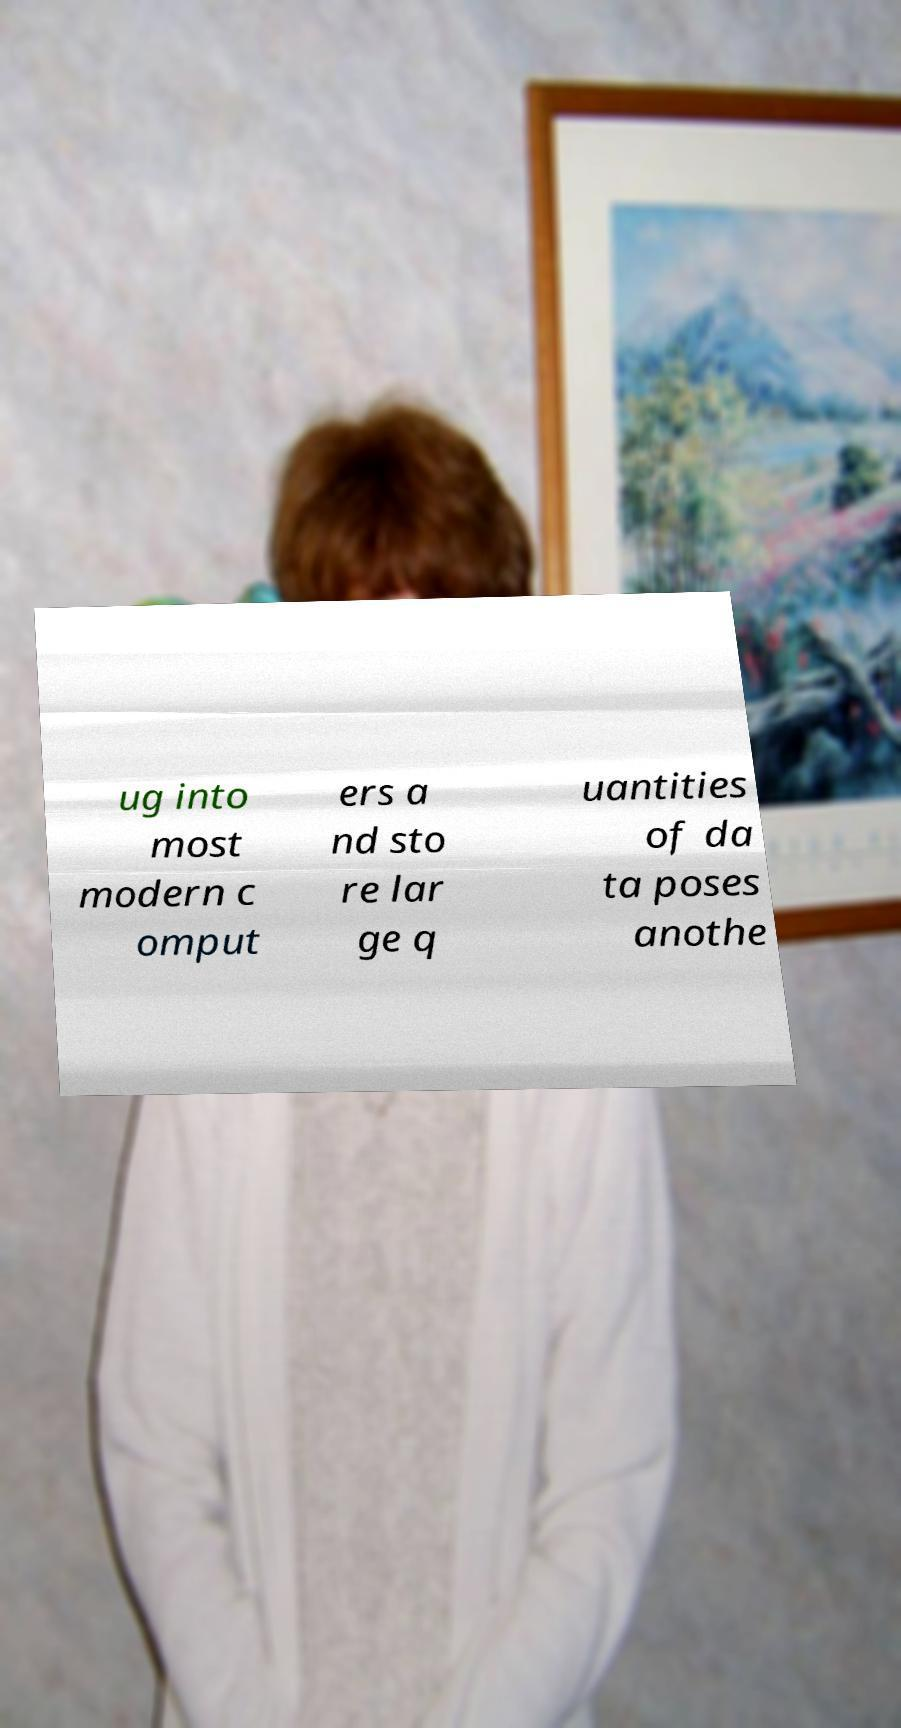Please identify and transcribe the text found in this image. ug into most modern c omput ers a nd sto re lar ge q uantities of da ta poses anothe 